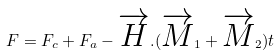Convert formula to latex. <formula><loc_0><loc_0><loc_500><loc_500>F = F _ { c } + F _ { a } - \overrightarrow { H } . ( \overrightarrow { M } _ { 1 } + \overrightarrow { M } _ { 2 } ) t</formula> 